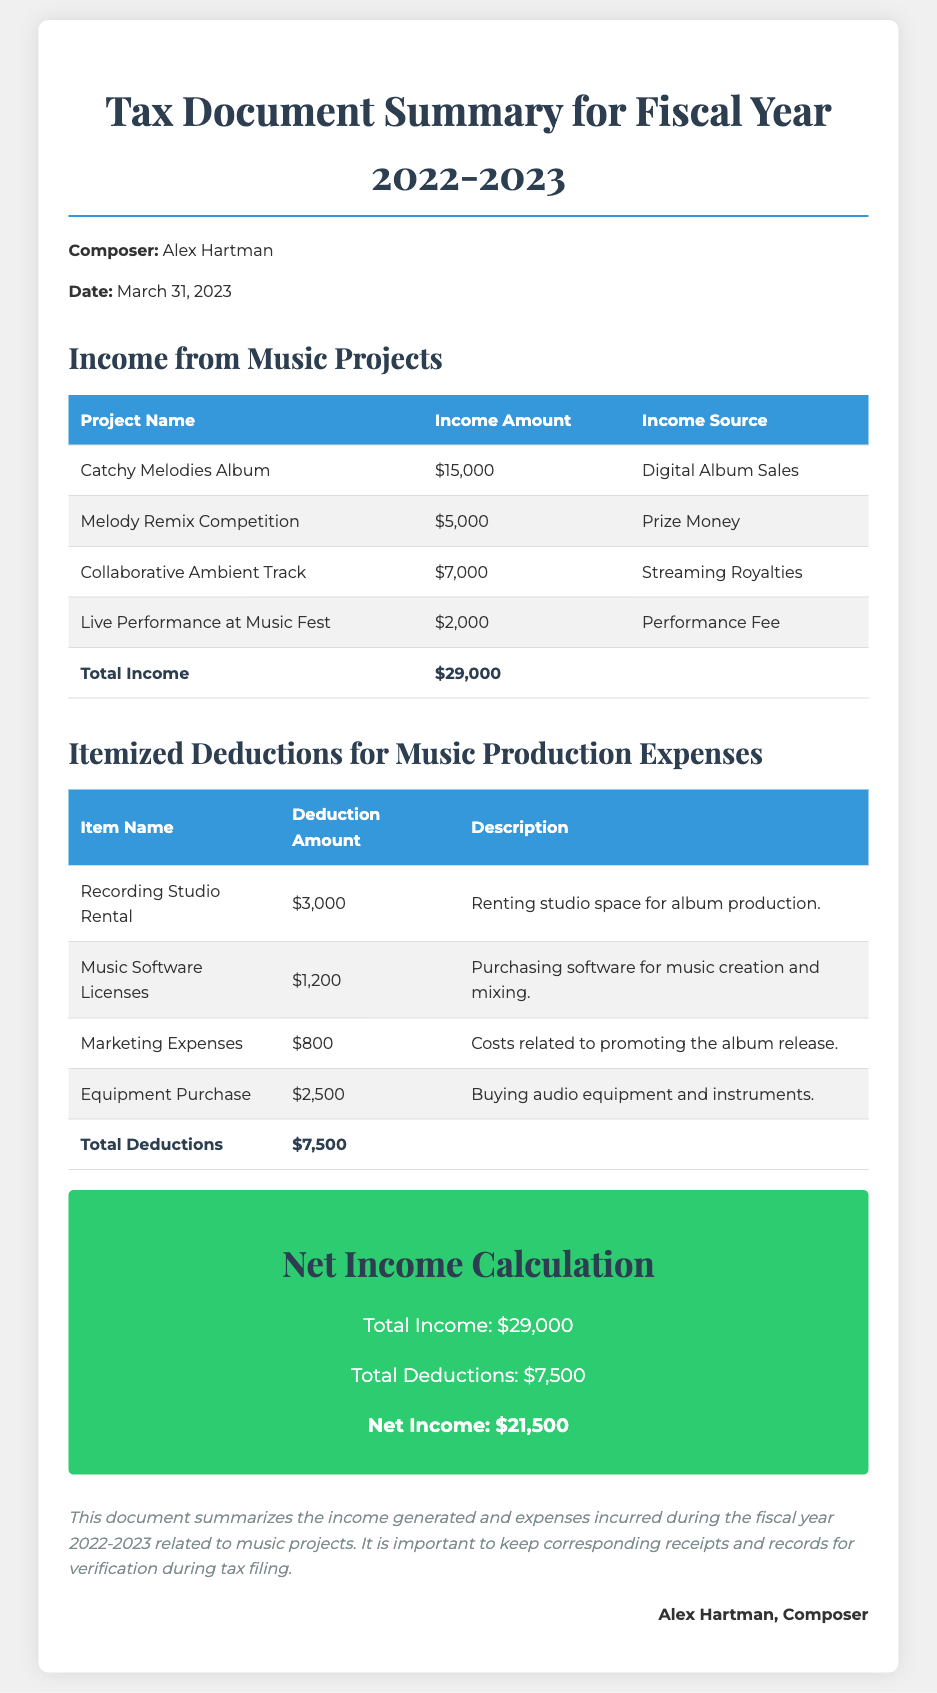What is the total income? The total income is found in the summary at the bottom of the income table, which adds all income sources together: $15,000 + $5,000 + $7,000 + $2,000 = $29,000.
Answer: $29,000 What is the total deduction? The total deductions are listed at the bottom of the itemized deductions table, which sums all expense items: $3,000 + $1,200 + $800 + $2,500 = $7,500.
Answer: $7,500 What is the net income? The net income is calculated by subtracting the total deductions from the total income as shown in the net income calculation section: $29,000 - $7,500 = $21,500.
Answer: $21,500 Which project generated the highest income? The project with the highest income is listed at the top of the income table, which is the "Catchy Melodies Album" with an income of $15,000.
Answer: Catchy Melodies Album What is the date of the document? The document date is stated near the top of the document, which is March 31, 2023.
Answer: March 31, 2023 How much was spent on marketing expenses? The marketing expenses amount is included in the itemized deductions table, specifically listed as $800.
Answer: $800 How many projects generated income? The number of projects is determined by counting the entries in the income table, which lists four distinct projects.
Answer: Four What type of expenses were itemized? The type of expenses is indicated in the itemized deductions section, which includes studio rental, software licenses, marketing expenses, and equipment purchase.
Answer: Music production expenses Who is the composer? The composer's name is stated at the beginning of the document as Alex Hartman.
Answer: Alex Hartman 